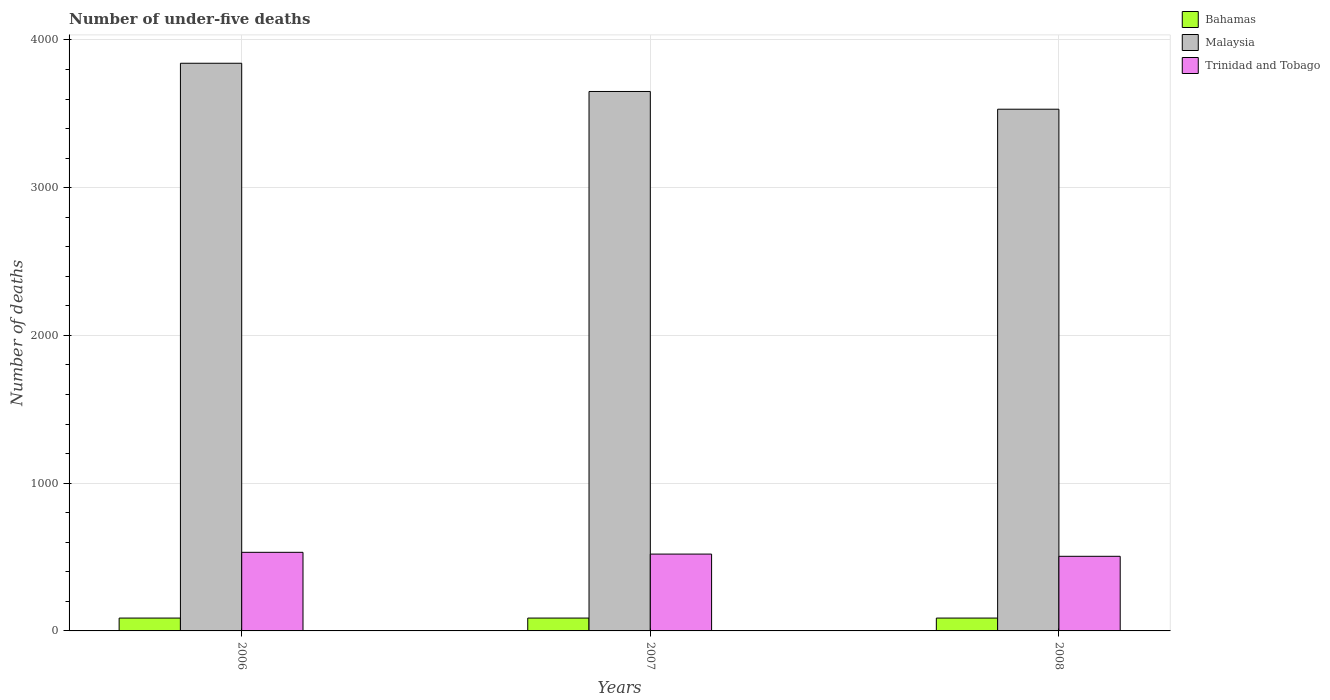How many different coloured bars are there?
Your answer should be compact. 3. How many groups of bars are there?
Ensure brevity in your answer.  3. What is the label of the 1st group of bars from the left?
Provide a short and direct response. 2006. In how many cases, is the number of bars for a given year not equal to the number of legend labels?
Your response must be concise. 0. What is the number of under-five deaths in Bahamas in 2006?
Provide a succinct answer. 87. Across all years, what is the minimum number of under-five deaths in Trinidad and Tobago?
Offer a very short reply. 505. In which year was the number of under-five deaths in Bahamas minimum?
Your answer should be compact. 2006. What is the total number of under-five deaths in Trinidad and Tobago in the graph?
Keep it short and to the point. 1557. What is the difference between the number of under-five deaths in Bahamas in 2006 and that in 2008?
Provide a short and direct response. 0. What is the difference between the number of under-five deaths in Malaysia in 2007 and the number of under-five deaths in Trinidad and Tobago in 2008?
Your response must be concise. 3146. What is the average number of under-five deaths in Malaysia per year?
Ensure brevity in your answer.  3674.67. In the year 2006, what is the difference between the number of under-five deaths in Trinidad and Tobago and number of under-five deaths in Malaysia?
Keep it short and to the point. -3310. What is the difference between the highest and the second highest number of under-five deaths in Trinidad and Tobago?
Provide a short and direct response. 12. What is the difference between the highest and the lowest number of under-five deaths in Malaysia?
Your answer should be very brief. 311. What does the 2nd bar from the left in 2008 represents?
Provide a succinct answer. Malaysia. What does the 1st bar from the right in 2008 represents?
Make the answer very short. Trinidad and Tobago. Is it the case that in every year, the sum of the number of under-five deaths in Trinidad and Tobago and number of under-five deaths in Malaysia is greater than the number of under-five deaths in Bahamas?
Give a very brief answer. Yes. How many bars are there?
Your response must be concise. 9. Are the values on the major ticks of Y-axis written in scientific E-notation?
Your response must be concise. No. Does the graph contain grids?
Offer a very short reply. Yes. Where does the legend appear in the graph?
Make the answer very short. Top right. How are the legend labels stacked?
Keep it short and to the point. Vertical. What is the title of the graph?
Keep it short and to the point. Number of under-five deaths. What is the label or title of the Y-axis?
Your answer should be compact. Number of deaths. What is the Number of deaths in Malaysia in 2006?
Offer a terse response. 3842. What is the Number of deaths in Trinidad and Tobago in 2006?
Your answer should be very brief. 532. What is the Number of deaths of Malaysia in 2007?
Your response must be concise. 3651. What is the Number of deaths in Trinidad and Tobago in 2007?
Provide a short and direct response. 520. What is the Number of deaths in Malaysia in 2008?
Ensure brevity in your answer.  3531. What is the Number of deaths in Trinidad and Tobago in 2008?
Give a very brief answer. 505. Across all years, what is the maximum Number of deaths of Bahamas?
Make the answer very short. 87. Across all years, what is the maximum Number of deaths of Malaysia?
Offer a terse response. 3842. Across all years, what is the maximum Number of deaths in Trinidad and Tobago?
Your answer should be compact. 532. Across all years, what is the minimum Number of deaths of Bahamas?
Provide a succinct answer. 87. Across all years, what is the minimum Number of deaths in Malaysia?
Your response must be concise. 3531. Across all years, what is the minimum Number of deaths in Trinidad and Tobago?
Offer a very short reply. 505. What is the total Number of deaths of Bahamas in the graph?
Provide a succinct answer. 261. What is the total Number of deaths in Malaysia in the graph?
Your answer should be very brief. 1.10e+04. What is the total Number of deaths of Trinidad and Tobago in the graph?
Provide a succinct answer. 1557. What is the difference between the Number of deaths in Bahamas in 2006 and that in 2007?
Offer a terse response. 0. What is the difference between the Number of deaths in Malaysia in 2006 and that in 2007?
Your answer should be compact. 191. What is the difference between the Number of deaths in Trinidad and Tobago in 2006 and that in 2007?
Offer a very short reply. 12. What is the difference between the Number of deaths in Bahamas in 2006 and that in 2008?
Your response must be concise. 0. What is the difference between the Number of deaths in Malaysia in 2006 and that in 2008?
Keep it short and to the point. 311. What is the difference between the Number of deaths in Bahamas in 2007 and that in 2008?
Give a very brief answer. 0. What is the difference between the Number of deaths in Malaysia in 2007 and that in 2008?
Give a very brief answer. 120. What is the difference between the Number of deaths of Bahamas in 2006 and the Number of deaths of Malaysia in 2007?
Offer a terse response. -3564. What is the difference between the Number of deaths in Bahamas in 2006 and the Number of deaths in Trinidad and Tobago in 2007?
Provide a short and direct response. -433. What is the difference between the Number of deaths in Malaysia in 2006 and the Number of deaths in Trinidad and Tobago in 2007?
Provide a succinct answer. 3322. What is the difference between the Number of deaths in Bahamas in 2006 and the Number of deaths in Malaysia in 2008?
Your response must be concise. -3444. What is the difference between the Number of deaths of Bahamas in 2006 and the Number of deaths of Trinidad and Tobago in 2008?
Ensure brevity in your answer.  -418. What is the difference between the Number of deaths in Malaysia in 2006 and the Number of deaths in Trinidad and Tobago in 2008?
Your response must be concise. 3337. What is the difference between the Number of deaths of Bahamas in 2007 and the Number of deaths of Malaysia in 2008?
Make the answer very short. -3444. What is the difference between the Number of deaths of Bahamas in 2007 and the Number of deaths of Trinidad and Tobago in 2008?
Provide a succinct answer. -418. What is the difference between the Number of deaths in Malaysia in 2007 and the Number of deaths in Trinidad and Tobago in 2008?
Provide a short and direct response. 3146. What is the average Number of deaths of Bahamas per year?
Give a very brief answer. 87. What is the average Number of deaths in Malaysia per year?
Your answer should be compact. 3674.67. What is the average Number of deaths in Trinidad and Tobago per year?
Provide a short and direct response. 519. In the year 2006, what is the difference between the Number of deaths of Bahamas and Number of deaths of Malaysia?
Make the answer very short. -3755. In the year 2006, what is the difference between the Number of deaths in Bahamas and Number of deaths in Trinidad and Tobago?
Offer a terse response. -445. In the year 2006, what is the difference between the Number of deaths of Malaysia and Number of deaths of Trinidad and Tobago?
Your response must be concise. 3310. In the year 2007, what is the difference between the Number of deaths of Bahamas and Number of deaths of Malaysia?
Offer a terse response. -3564. In the year 2007, what is the difference between the Number of deaths of Bahamas and Number of deaths of Trinidad and Tobago?
Provide a short and direct response. -433. In the year 2007, what is the difference between the Number of deaths of Malaysia and Number of deaths of Trinidad and Tobago?
Provide a short and direct response. 3131. In the year 2008, what is the difference between the Number of deaths in Bahamas and Number of deaths in Malaysia?
Give a very brief answer. -3444. In the year 2008, what is the difference between the Number of deaths in Bahamas and Number of deaths in Trinidad and Tobago?
Provide a succinct answer. -418. In the year 2008, what is the difference between the Number of deaths in Malaysia and Number of deaths in Trinidad and Tobago?
Provide a short and direct response. 3026. What is the ratio of the Number of deaths in Malaysia in 2006 to that in 2007?
Provide a short and direct response. 1.05. What is the ratio of the Number of deaths of Trinidad and Tobago in 2006 to that in 2007?
Provide a succinct answer. 1.02. What is the ratio of the Number of deaths of Malaysia in 2006 to that in 2008?
Offer a terse response. 1.09. What is the ratio of the Number of deaths of Trinidad and Tobago in 2006 to that in 2008?
Ensure brevity in your answer.  1.05. What is the ratio of the Number of deaths in Bahamas in 2007 to that in 2008?
Keep it short and to the point. 1. What is the ratio of the Number of deaths in Malaysia in 2007 to that in 2008?
Offer a terse response. 1.03. What is the ratio of the Number of deaths of Trinidad and Tobago in 2007 to that in 2008?
Your answer should be compact. 1.03. What is the difference between the highest and the second highest Number of deaths in Bahamas?
Your answer should be compact. 0. What is the difference between the highest and the second highest Number of deaths in Malaysia?
Offer a terse response. 191. What is the difference between the highest and the lowest Number of deaths in Bahamas?
Offer a terse response. 0. What is the difference between the highest and the lowest Number of deaths in Malaysia?
Ensure brevity in your answer.  311. 